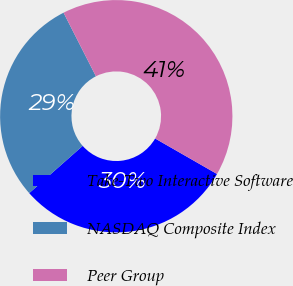Convert chart. <chart><loc_0><loc_0><loc_500><loc_500><pie_chart><fcel>Take-Two Interactive Software<fcel>NASDAQ Composite Index<fcel>Peer Group<nl><fcel>30.2%<fcel>29.02%<fcel>40.78%<nl></chart> 